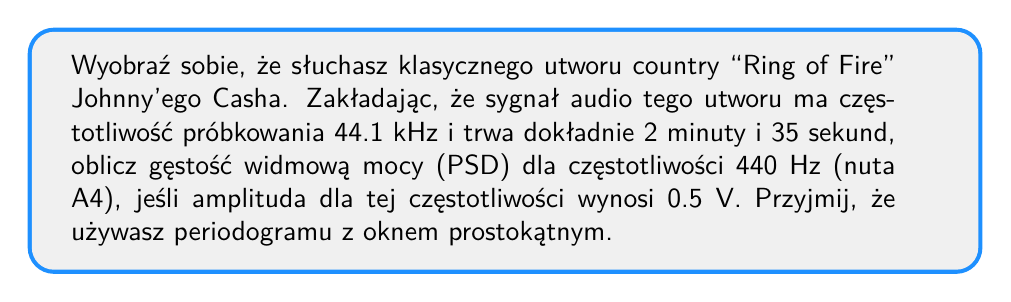Teach me how to tackle this problem. Aby obliczyć gęstość widmową mocy (PSD) dla określonej częstotliwości, wykonamy następujące kroki:

1. Obliczmy całkowitą liczbę próbek N:
   Czas trwania = 2 min 35 s = 155 s
   $N = 155 \text{ s} \times 44100 \text{ Hz} = 6835500$ próbek

2. Obliczmy rozdzielczość częstotliwościową $\Delta f$:
   $$\Delta f = \frac{f_s}{N} = \frac{44100}{6835500} \approx 0.00645 \text{ Hz}$$

3. Dla okna prostokątnego, periodogram jest kwadratem modułu transformaty Fouriera podzielonym przez całkowitą liczbę próbek:
   $$P_{xx}(f) = \frac{|X(f)|^2}{N}$$

   gdzie $X(f)$ to transformata Fouriera sygnału.

4. Dla pojedynczej składowej sinusoidalnej o amplitudzie A:
   $$|X(f)|^2 \approx \frac{N^2A^2}{4}$$

5. Podstawiając do wzoru na periodogram:
   $$P_{xx}(f) = \frac{|X(f)|^2}{N} = \frac{N^2A^2}{4N} = \frac{NA^2}{4}$$

6. Obliczmy PSD dla częstotliwości 440 Hz:
   $$P_{xx}(440 \text{ Hz}) = \frac{6835500 \times 0.5^2}{4} = 427218.75 \text{ V}^2/\text{Hz}$$

7. Aby otrzymać jednostkę W/Hz, zakładamy impedancję 1 Ω:
   $$P_{xx}(440 \text{ Hz}) = 427218.75 \text{ W}/\text{Hz}$$
Answer: $427218.75 \text{ W}/\text{Hz}$ 